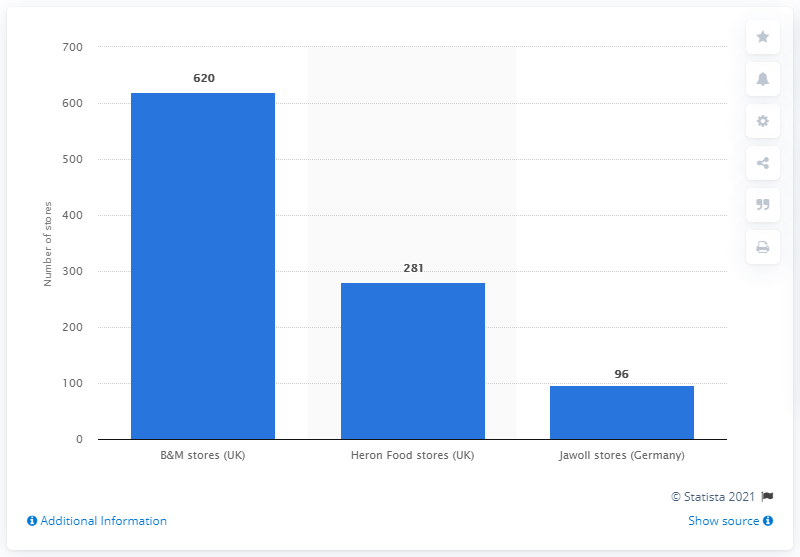Identify some key points in this picture. The B&M Group owns 620 B&M stores. There are 96 Jawoll stores in Germany. 